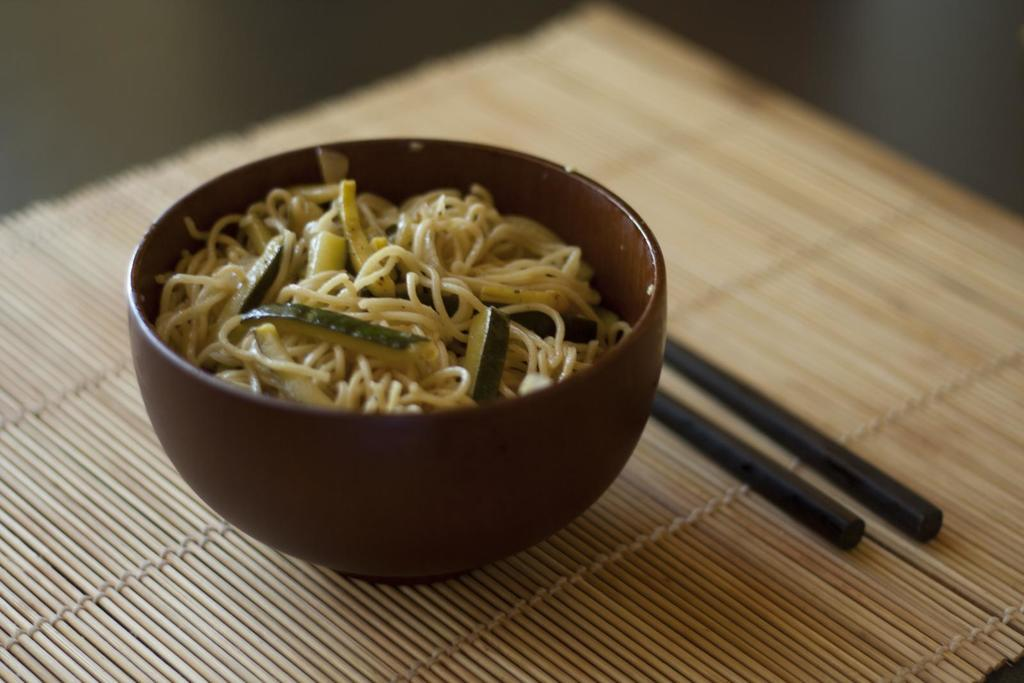What type of food is in the bowl in the image? There are noodles in a bowl in the image. What accompanies the noodles in the bowl? There are vegetable slices in the bowl. What utensil is used to eat the noodles? Chopsticks are present in the image. What type of table is the bowl placed on? The wooden dining table is mentioned in the image. What is on top of the wooden dining table? The wooden dining table has a mat on it. How is the wooden dining table positioned? The wooden dining table is on a platform. What type of coat is hanging on the street in the image? There is no coat or street present in the image; it features a bowl of noodles, and vegetable slices on a wooden dining table. 